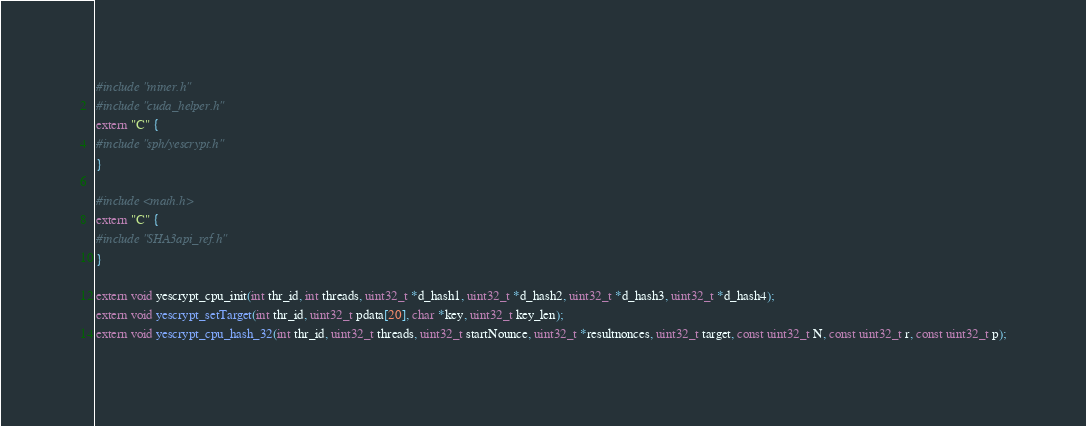Convert code to text. <code><loc_0><loc_0><loc_500><loc_500><_Cuda_>#include "miner.h"
#include "cuda_helper.h"
extern "C" {
#include "sph/yescrypt.h"
}

#include <math.h>
extern "C" {
#include "SHA3api_ref.h"
}

extern void yescrypt_cpu_init(int thr_id, int threads, uint32_t *d_hash1, uint32_t *d_hash2, uint32_t *d_hash3, uint32_t *d_hash4);
extern void yescrypt_setTarget(int thr_id, uint32_t pdata[20], char *key, uint32_t key_len);
extern void yescrypt_cpu_hash_32(int thr_id, uint32_t threads, uint32_t startNounce, uint32_t *resultnonces, uint32_t target, const uint32_t N, const uint32_t r, const uint32_t p);</code> 